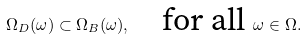<formula> <loc_0><loc_0><loc_500><loc_500>\Omega _ { D } ( \omega ) \subset \Omega _ { B } ( \omega ) , \quad \text {for all } \omega \in \Omega .</formula> 